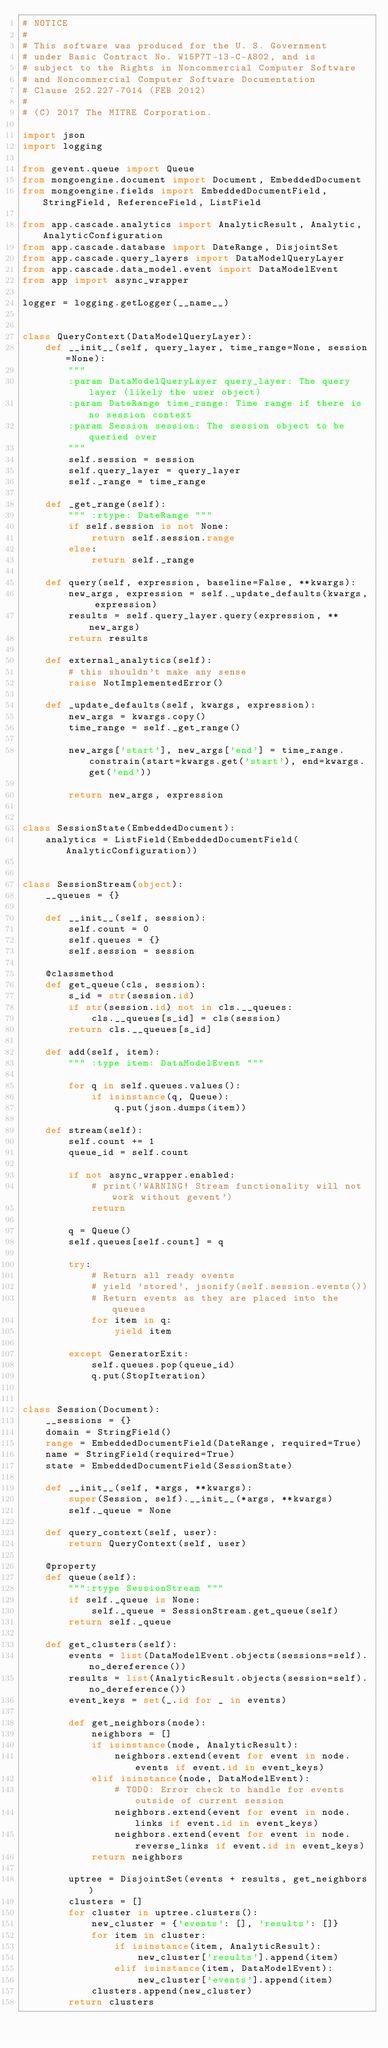<code> <loc_0><loc_0><loc_500><loc_500><_Python_># NOTICE
#
# This software was produced for the U. S. Government
# under Basic Contract No. W15P7T-13-C-A802, and is
# subject to the Rights in Noncommercial Computer Software
# and Noncommercial Computer Software Documentation
# Clause 252.227-7014 (FEB 2012)
#
# (C) 2017 The MITRE Corporation.

import json
import logging

from gevent.queue import Queue
from mongoengine.document import Document, EmbeddedDocument
from mongoengine.fields import EmbeddedDocumentField, StringField, ReferenceField, ListField

from app.cascade.analytics import AnalyticResult, Analytic, AnalyticConfiguration
from app.cascade.database import DateRange, DisjointSet
from app.cascade.query_layers import DataModelQueryLayer
from app.cascade.data_model.event import DataModelEvent
from app import async_wrapper

logger = logging.getLogger(__name__)


class QueryContext(DataModelQueryLayer):
    def __init__(self, query_layer, time_range=None, session=None):
        """
        :param DataModelQueryLayer query_layer: The query layer (likely the user object)
        :param DateRange time_range: Time range if there is no session context
        :param Session session: The session object to be queried over
        """
        self.session = session
        self.query_layer = query_layer
        self._range = time_range

    def _get_range(self):
        """ :rtype: DateRange """
        if self.session is not None:
            return self.session.range
        else:
            return self._range

    def query(self, expression, baseline=False, **kwargs):
        new_args, expression = self._update_defaults(kwargs, expression)
        results = self.query_layer.query(expression, **new_args)
        return results

    def external_analytics(self):
        # this shouldn't make any sense
        raise NotImplementedError()

    def _update_defaults(self, kwargs, expression):
        new_args = kwargs.copy()
        time_range = self._get_range()

        new_args['start'], new_args['end'] = time_range.constrain(start=kwargs.get('start'), end=kwargs.get('end'))

        return new_args, expression


class SessionState(EmbeddedDocument):
    analytics = ListField(EmbeddedDocumentField(AnalyticConfiguration))


class SessionStream(object):
    __queues = {}

    def __init__(self, session):
        self.count = 0
        self.queues = {}
        self.session = session

    @classmethod
    def get_queue(cls, session):
        s_id = str(session.id)
        if str(session.id) not in cls.__queues:
            cls.__queues[s_id] = cls(session)
        return cls.__queues[s_id]

    def add(self, item):
        """ :type item: DataModelEvent """

        for q in self.queues.values():
            if isinstance(q, Queue):
                q.put(json.dumps(item))

    def stream(self):
        self.count += 1
        queue_id = self.count

        if not async_wrapper.enabled:
            # print('WARNING! Stream functionality will not work without gevent')
            return

        q = Queue()
        self.queues[self.count] = q

        try:
            # Return all ready events
            # yield 'stored', jsonify(self.session.events())
            # Return events as they are placed into the queues
            for item in q:
                yield item

        except GeneratorExit:
            self.queues.pop(queue_id)
            q.put(StopIteration)


class Session(Document):
    __sessions = {}
    domain = StringField()
    range = EmbeddedDocumentField(DateRange, required=True)
    name = StringField(required=True)
    state = EmbeddedDocumentField(SessionState)

    def __init__(self, *args, **kwargs):
        super(Session, self).__init__(*args, **kwargs)
        self._queue = None

    def query_context(self, user):
        return QueryContext(self, user)

    @property
    def queue(self):
        """:rtype SessionStream """
        if self._queue is None:
            self._queue = SessionStream.get_queue(self)
        return self._queue

    def get_clusters(self):
        events = list(DataModelEvent.objects(sessions=self).no_dereference())
        results = list(AnalyticResult.objects(session=self).no_dereference())
        event_keys = set(_.id for _ in events)

        def get_neighbors(node):
            neighbors = []
            if isinstance(node, AnalyticResult):
                neighbors.extend(event for event in node.events if event.id in event_keys)
            elif isinstance(node, DataModelEvent):
                # TODO: Error check to handle for events outside of current session
                neighbors.extend(event for event in node.links if event.id in event_keys)
                neighbors.extend(event for event in node.reverse_links if event.id in event_keys)
            return neighbors

        uptree = DisjointSet(events + results, get_neighbors)
        clusters = []
        for cluster in uptree.clusters():
            new_cluster = {'events': [], 'results': []}
            for item in cluster:
                if isinstance(item, AnalyticResult):
                    new_cluster['results'].append(item)
                elif isinstance(item, DataModelEvent):
                    new_cluster['events'].append(item)
            clusters.append(new_cluster)
        return clusters


</code> 